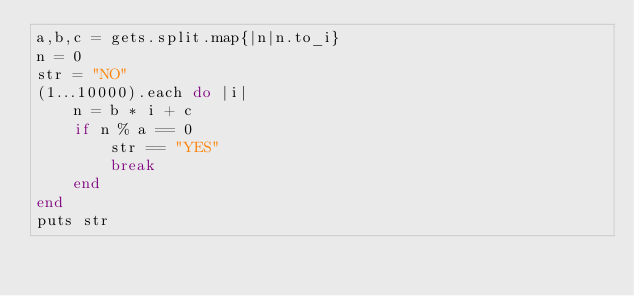<code> <loc_0><loc_0><loc_500><loc_500><_Ruby_>a,b,c = gets.split.map{|n|n.to_i}
n = 0
str = "NO"
(1...10000).each do |i|
    n = b * i + c
    if n % a == 0
        str == "YES"
        break
    end
end
puts str</code> 